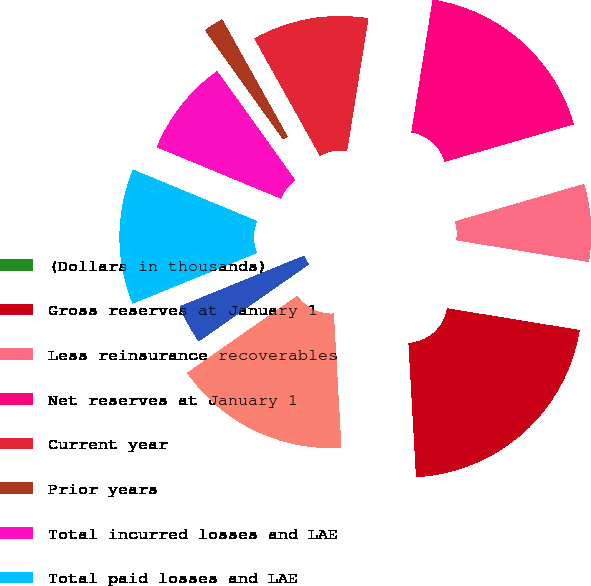Convert chart. <chart><loc_0><loc_0><loc_500><loc_500><pie_chart><fcel>(Dollars in thousands)<fcel>Gross reserves at January 1<fcel>Less reinsurance recoverables<fcel>Net reserves at January 1<fcel>Current year<fcel>Prior years<fcel>Total incurred losses and LAE<fcel>Total paid losses and LAE<fcel>Foreign exchange/translation<fcel>Net reserves at December 31<nl><fcel>0.0%<fcel>21.51%<fcel>7.09%<fcel>17.97%<fcel>10.64%<fcel>1.78%<fcel>8.86%<fcel>12.41%<fcel>3.55%<fcel>16.19%<nl></chart> 